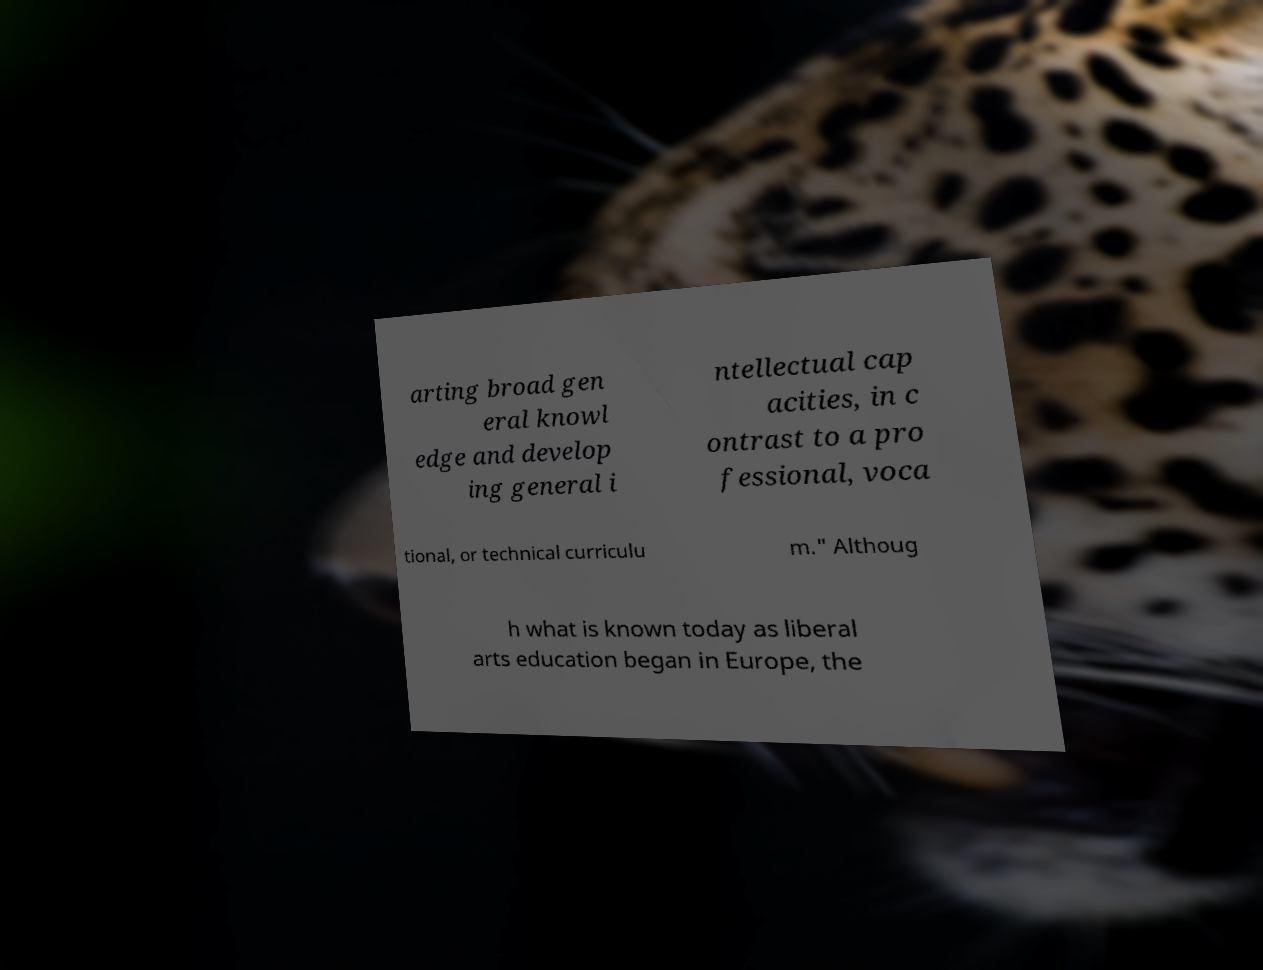Please read and relay the text visible in this image. What does it say? arting broad gen eral knowl edge and develop ing general i ntellectual cap acities, in c ontrast to a pro fessional, voca tional, or technical curriculu m." Althoug h what is known today as liberal arts education began in Europe, the 